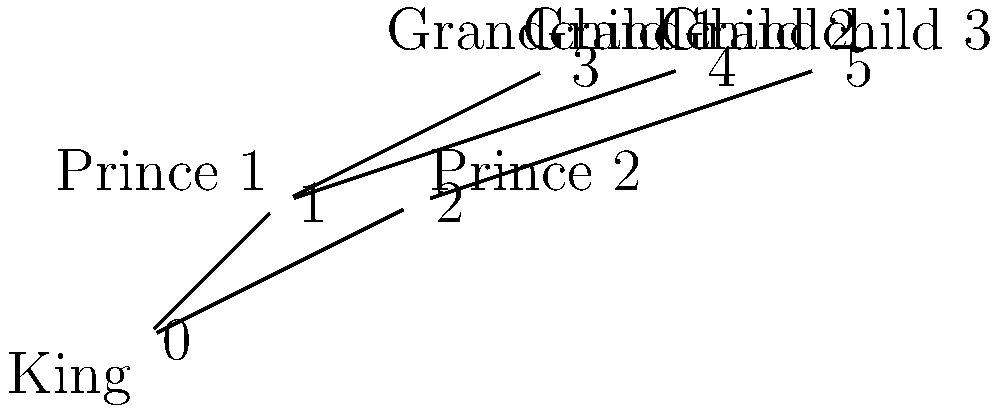In the context of representing royal dynasties using group theory, how would you interpret the permutation $\sigma = (0\,1\,3)(2\,5\,4)$ applied to the genealogical tree shown above? What historical scenario might this permutation represent? To interpret the permutation $\sigma = (0\,1\,3)(2\,5\,4)$ in the context of the given genealogical tree, we need to follow these steps:

1. Understand the initial tree structure:
   - Node 0 represents the King
   - Nodes 1 and 2 represent Prince 1 and Prince 2
   - Nodes 3, 4, and 5 represent Grandchildren 1, 2, and 3

2. Apply the first cycle $(0\,1\,3)$:
   - 0 (King) moves to 1's position (Prince 1)
   - 1 (Prince 1) moves to 3's position (Grandchild 1)
   - 3 (Grandchild 1) moves to 0's position (King)

3. Apply the second cycle $(2\,5\,4)$:
   - 2 (Prince 2) moves to 5's position (Grandchild 3)
   - 5 (Grandchild 3) moves to 4's position (Grandchild 2)
   - 4 (Grandchild 2) moves to 2's position (Prince 2)

4. Interpret the historical scenario:
   - The King (0) is replaced by Grandchild 1 (3)
   - Prince 1 (1) becomes the new King
   - Grandchild 1 (3) takes Prince 1's position
   - Prince 2 (2) is replaced by Grandchild 2 (4)
   - Grandchild 3 (5) takes Grandchild 2's position
   - Grandchild 2 (4) becomes the new Prince 2

This permutation could represent a complex succession scenario where:
- The original King abdicates or dies
- Prince 1 ascends to the throne
- Grandchild 1 is elevated to Prince status
- Prince 2 is removed from succession
- Grandchildren 2 and 3 are repositioned in the line of succession

Such a scenario might occur due to political maneuvering, changes in laws of succession, or other historical events that dramatically alter the royal family structure.
Answer: Succession crisis: King abdicates, Prince 1 ascends, Grandchild 1 becomes Prince, Prince 2 removed, succession order of Grandchildren altered. 